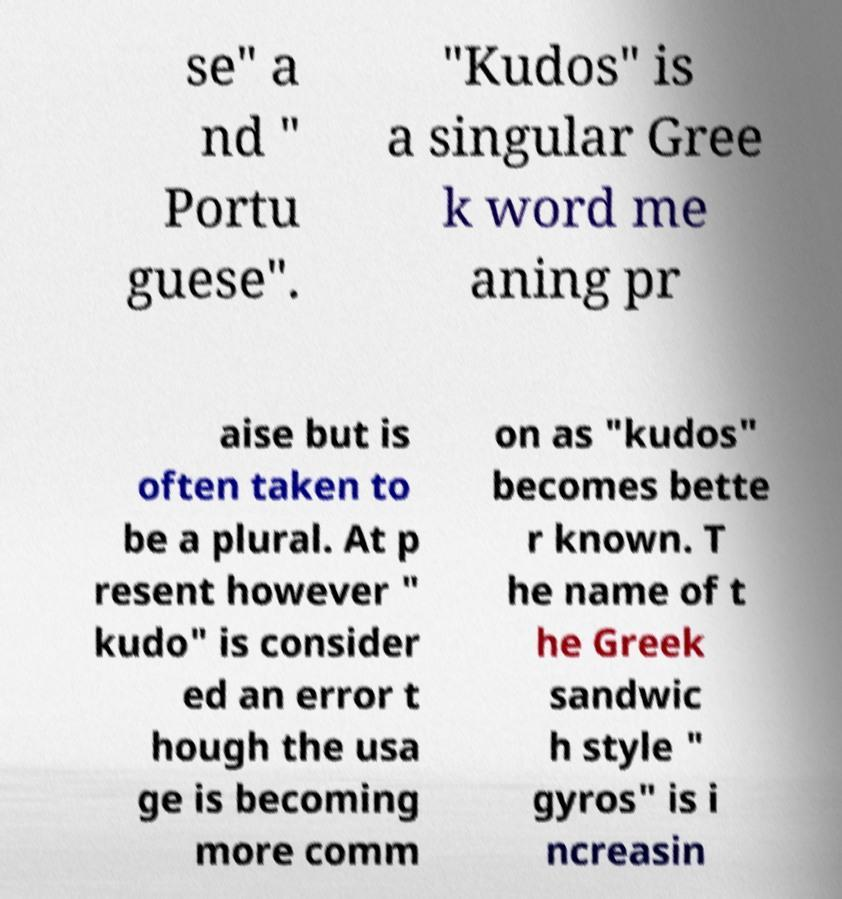I need the written content from this picture converted into text. Can you do that? se" a nd " Portu guese". "Kudos" is a singular Gree k word me aning pr aise but is often taken to be a plural. At p resent however " kudo" is consider ed an error t hough the usa ge is becoming more comm on as "kudos" becomes bette r known. T he name of t he Greek sandwic h style " gyros" is i ncreasin 